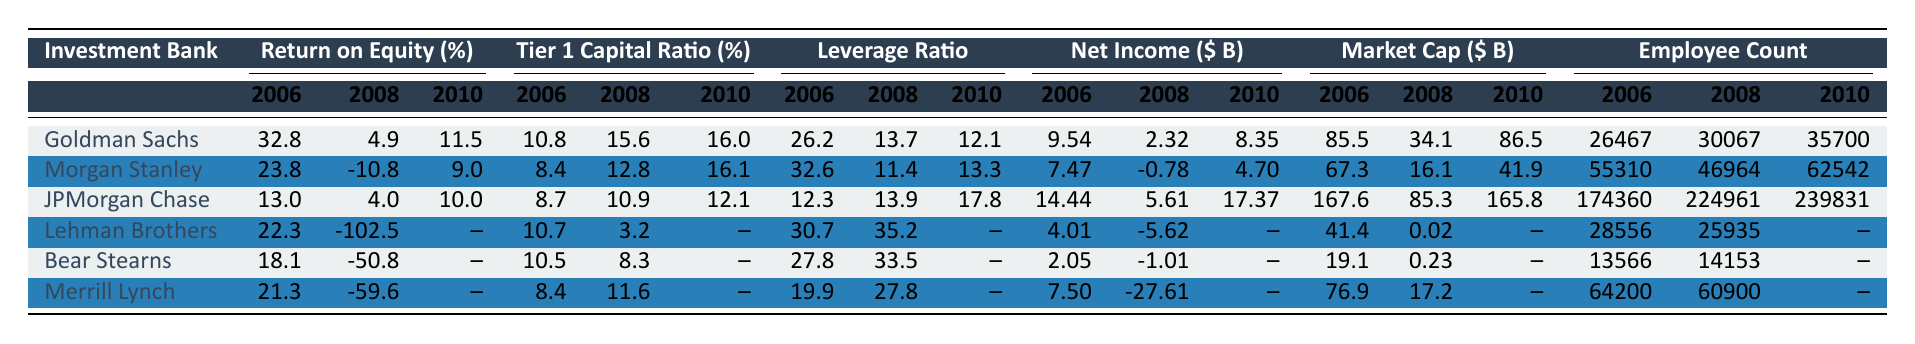What was the Return on Equity for Goldman Sachs in 2008? The table shows the Return on Equity for Goldman Sachs in 2008 as 4.9%.
Answer: 4.9% What is the Tier 1 Capital Ratio for Morgan Stanley in 2010? Referring to the table, Morgan Stanley's Tier 1 Capital Ratio in 2010 is 16.1%.
Answer: 16.1% Which investment bank had the highest Net Income in 2010? By comparing the Net Income values for all banks in 2010, JPMorgan Chase recorded the highest at $17.37 billion.
Answer: JPMorgan Chase What was the change in Employee Count for Goldman Sachs from 2006 to 2010? The Employee Count for Goldman Sachs in 2006 was 26,467 and in 2010 it was 35,700. The change is 35,700 - 26,467 = 9,233.
Answer: 9,233 Was Lehman Brothers still operational in 2010? The table shows missing data for Lehman Brothers in 2010, indicating its closure by that year.
Answer: No What is the average Return on Equity of the banks listed in 2006? The Return on Equity values for the banks in 2006 are 32.8, 23.8, 13.0, 22.3, 18.1, and 21.3. The average is (32.8 + 23.8 + 13.0 + 22.3 + 18.1 + 21.3) / 6 = 20.5%.
Answer: 20.5% Which bank had the lowest Market Capitalization in 2008? By reviewing the Market Capitalization values for 2008, Bear Stearns had the lowest at $0.23 billion.
Answer: Bear Stearns What was the highest Leverage Ratio among the banks in 2008? The highest Leverage Ratio in 2008 is noted for Lehman Brothers at 35.2.
Answer: 35.2 Compare the Net Income of JPMorgan Chase and Bear Stearns in 2008. JPMorgan Chase had a Net Income of $5.61 billion, while Bear Stearns had a Net Income of -$1.01 billion. The difference is 5.61 - (-1.01) = 6.62 billion.
Answer: 6.62 billion Did any of the investment banks report a negative Net Income in 2008? Yes, both Morgan Stanley and Merrill Lynch reported negative Net Incomes, with Morgan Stanley at -$0.78 billion and Merrill Lynch at -$27.61 billion.
Answer: Yes What was the trend in Return on Equity for Morgan Stanley from 2006 to 2010? Morgan Stanley's Return on Equity dropped from 23.8% in 2006 to -10.8% in 2008, then improved to 9.0% in 2010, showing a recovery trend after the crisis.
Answer: Improved after 2008 